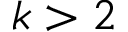<formula> <loc_0><loc_0><loc_500><loc_500>k > 2</formula> 